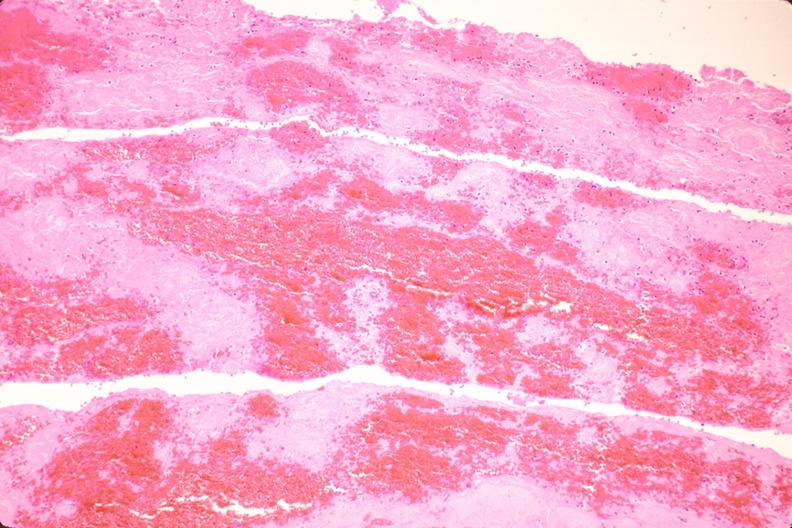what is present?
Answer the question using a single word or phrase. Cardiovascular 